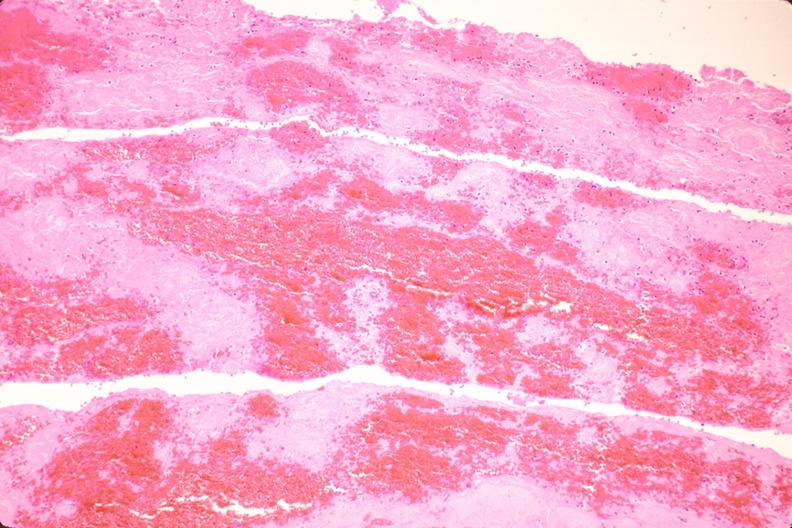what is present?
Answer the question using a single word or phrase. Cardiovascular 